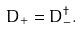Convert formula to latex. <formula><loc_0><loc_0><loc_500><loc_500>D _ { + } = D _ { - } ^ { \dagger } .</formula> 